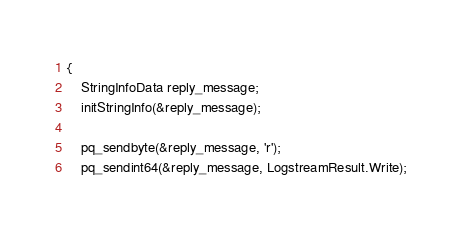Convert code to text. <code><loc_0><loc_0><loc_500><loc_500><_C_>{
	StringInfoData reply_message;
	initStringInfo(&reply_message);

	pq_sendbyte(&reply_message, 'r');
	pq_sendint64(&reply_message, LogstreamResult.Write);</code> 